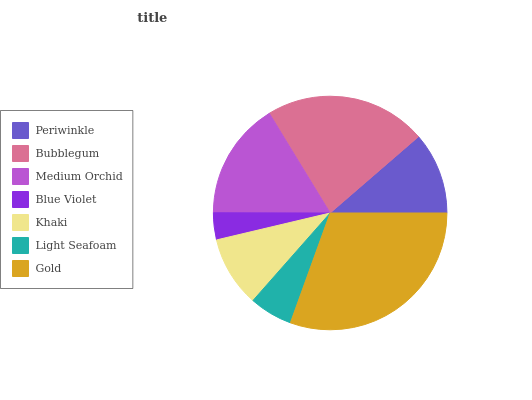Is Blue Violet the minimum?
Answer yes or no. Yes. Is Gold the maximum?
Answer yes or no. Yes. Is Bubblegum the minimum?
Answer yes or no. No. Is Bubblegum the maximum?
Answer yes or no. No. Is Bubblegum greater than Periwinkle?
Answer yes or no. Yes. Is Periwinkle less than Bubblegum?
Answer yes or no. Yes. Is Periwinkle greater than Bubblegum?
Answer yes or no. No. Is Bubblegum less than Periwinkle?
Answer yes or no. No. Is Periwinkle the high median?
Answer yes or no. Yes. Is Periwinkle the low median?
Answer yes or no. Yes. Is Light Seafoam the high median?
Answer yes or no. No. Is Light Seafoam the low median?
Answer yes or no. No. 